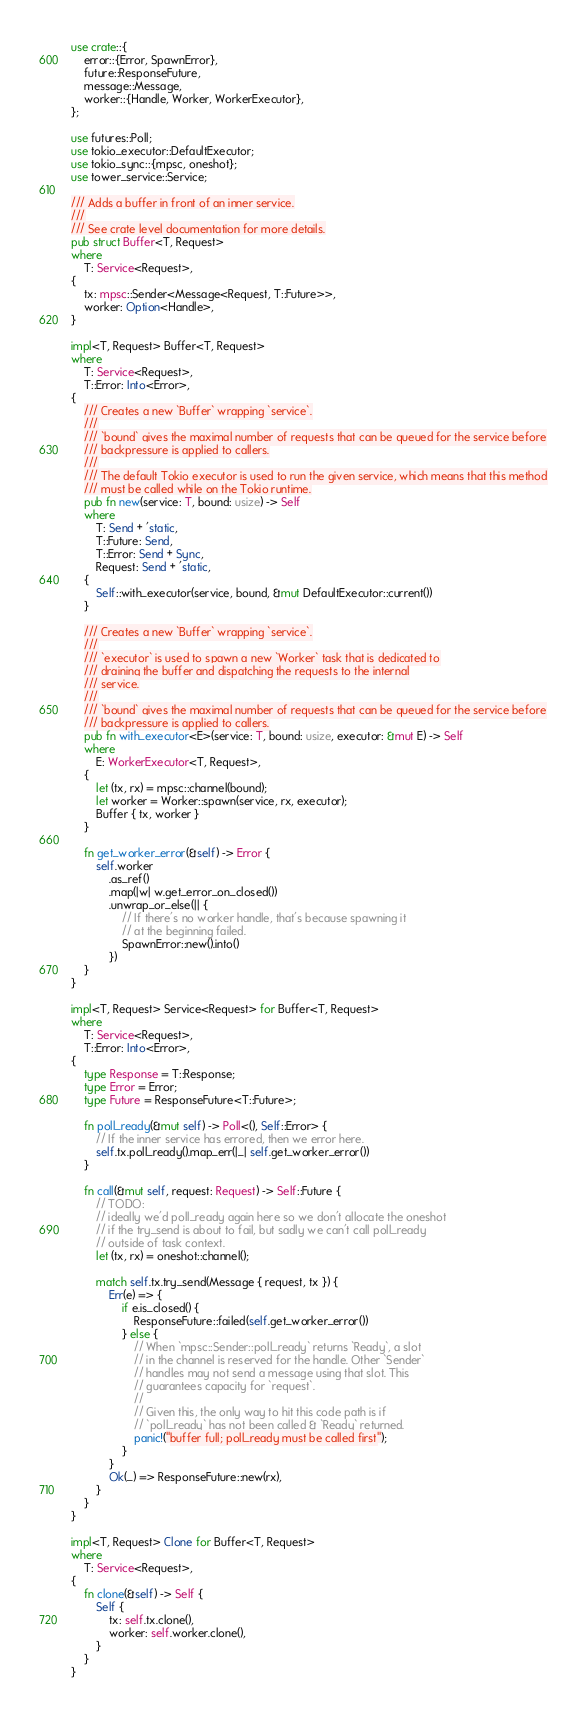Convert code to text. <code><loc_0><loc_0><loc_500><loc_500><_Rust_>use crate::{
    error::{Error, SpawnError},
    future::ResponseFuture,
    message::Message,
    worker::{Handle, Worker, WorkerExecutor},
};

use futures::Poll;
use tokio_executor::DefaultExecutor;
use tokio_sync::{mpsc, oneshot};
use tower_service::Service;

/// Adds a buffer in front of an inner service.
///
/// See crate level documentation for more details.
pub struct Buffer<T, Request>
where
    T: Service<Request>,
{
    tx: mpsc::Sender<Message<Request, T::Future>>,
    worker: Option<Handle>,
}

impl<T, Request> Buffer<T, Request>
where
    T: Service<Request>,
    T::Error: Into<Error>,
{
    /// Creates a new `Buffer` wrapping `service`.
    ///
    /// `bound` gives the maximal number of requests that can be queued for the service before
    /// backpressure is applied to callers.
    ///
    /// The default Tokio executor is used to run the given service, which means that this method
    /// must be called while on the Tokio runtime.
    pub fn new(service: T, bound: usize) -> Self
    where
        T: Send + 'static,
        T::Future: Send,
        T::Error: Send + Sync,
        Request: Send + 'static,
    {
        Self::with_executor(service, bound, &mut DefaultExecutor::current())
    }

    /// Creates a new `Buffer` wrapping `service`.
    ///
    /// `executor` is used to spawn a new `Worker` task that is dedicated to
    /// draining the buffer and dispatching the requests to the internal
    /// service.
    ///
    /// `bound` gives the maximal number of requests that can be queued for the service before
    /// backpressure is applied to callers.
    pub fn with_executor<E>(service: T, bound: usize, executor: &mut E) -> Self
    where
        E: WorkerExecutor<T, Request>,
    {
        let (tx, rx) = mpsc::channel(bound);
        let worker = Worker::spawn(service, rx, executor);
        Buffer { tx, worker }
    }

    fn get_worker_error(&self) -> Error {
        self.worker
            .as_ref()
            .map(|w| w.get_error_on_closed())
            .unwrap_or_else(|| {
                // If there's no worker handle, that's because spawning it
                // at the beginning failed.
                SpawnError::new().into()
            })
    }
}

impl<T, Request> Service<Request> for Buffer<T, Request>
where
    T: Service<Request>,
    T::Error: Into<Error>,
{
    type Response = T::Response;
    type Error = Error;
    type Future = ResponseFuture<T::Future>;

    fn poll_ready(&mut self) -> Poll<(), Self::Error> {
        // If the inner service has errored, then we error here.
        self.tx.poll_ready().map_err(|_| self.get_worker_error())
    }

    fn call(&mut self, request: Request) -> Self::Future {
        // TODO:
        // ideally we'd poll_ready again here so we don't allocate the oneshot
        // if the try_send is about to fail, but sadly we can't call poll_ready
        // outside of task context.
        let (tx, rx) = oneshot::channel();

        match self.tx.try_send(Message { request, tx }) {
            Err(e) => {
                if e.is_closed() {
                    ResponseFuture::failed(self.get_worker_error())
                } else {
                    // When `mpsc::Sender::poll_ready` returns `Ready`, a slot
                    // in the channel is reserved for the handle. Other `Sender`
                    // handles may not send a message using that slot. This
                    // guarantees capacity for `request`.
                    //
                    // Given this, the only way to hit this code path is if
                    // `poll_ready` has not been called & `Ready` returned.
                    panic!("buffer full; poll_ready must be called first");
                }
            }
            Ok(_) => ResponseFuture::new(rx),
        }
    }
}

impl<T, Request> Clone for Buffer<T, Request>
where
    T: Service<Request>,
{
    fn clone(&self) -> Self {
        Self {
            tx: self.tx.clone(),
            worker: self.worker.clone(),
        }
    }
}
</code> 